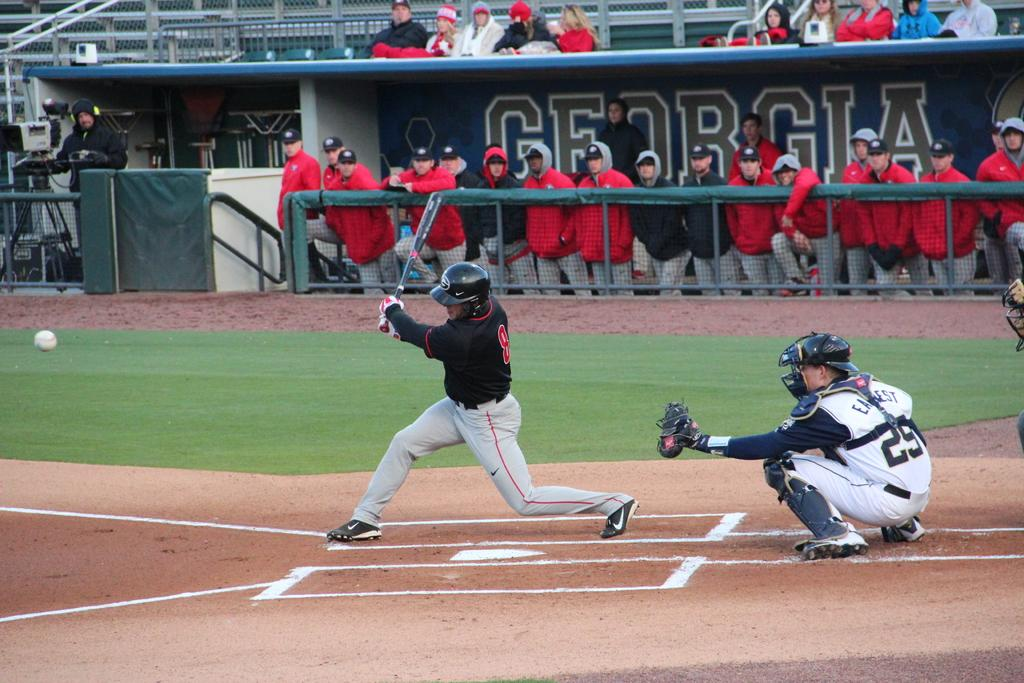<image>
Render a clear and concise summary of the photo. A baseball player at Georgia Stadium swings at a baseball with a catcher waiting. 